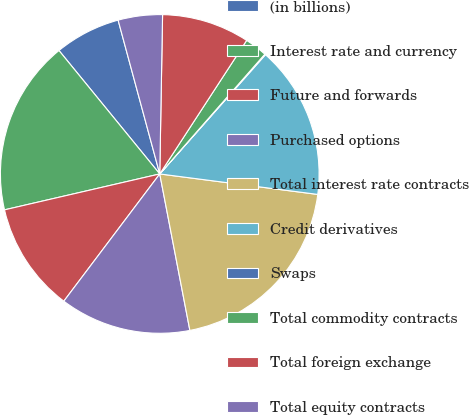Convert chart to OTSL. <chart><loc_0><loc_0><loc_500><loc_500><pie_chart><fcel>(in billions)<fcel>Interest rate and currency<fcel>Future and forwards<fcel>Purchased options<fcel>Total interest rate contracts<fcel>Credit derivatives<fcel>Swaps<fcel>Total commodity contracts<fcel>Total foreign exchange<fcel>Total equity contracts<nl><fcel>6.69%<fcel>17.72%<fcel>11.1%<fcel>13.31%<fcel>19.92%<fcel>15.51%<fcel>0.08%<fcel>2.28%<fcel>8.9%<fcel>4.49%<nl></chart> 